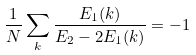Convert formula to latex. <formula><loc_0><loc_0><loc_500><loc_500>\frac { 1 } { N } \sum _ { k } \frac { E _ { 1 } ( k ) } { E _ { 2 } - 2 E _ { 1 } ( k ) } = - 1</formula> 